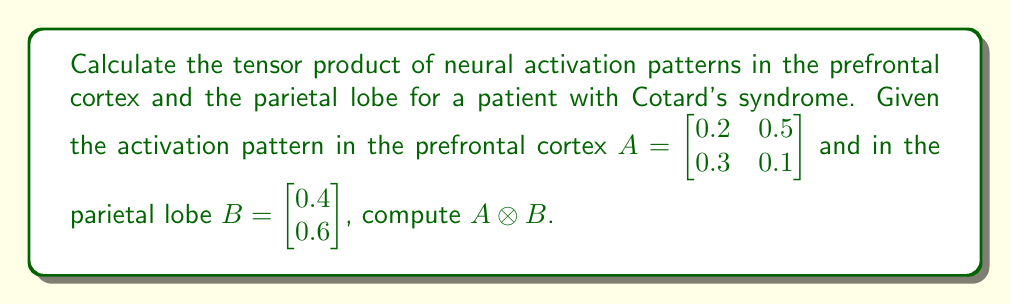Can you solve this math problem? To calculate the tensor product $A \otimes B$, we follow these steps:

1) The tensor product of a 2x2 matrix and a 2x1 vector results in a 4x2 matrix.

2) Each element of the resulting matrix is the product of an element from A and an element from B.

3) We can compute this systematically:

   $$(A \otimes B)_{ij,k} = A_{ij} \cdot B_k$$

   where $i,j \in \{1,2\}$ and $k \in \{1,2\}$

4) Let's compute each element:

   $$(A \otimes B)_{11,1} = A_{11} \cdot B_1 = 0.2 \cdot 0.4 = 0.08$$
   $$(A \otimes B)_{11,2} = A_{11} \cdot B_2 = 0.2 \cdot 0.6 = 0.12$$
   $$(A \otimes B)_{12,1} = A_{12} \cdot B_1 = 0.5 \cdot 0.4 = 0.20$$
   $$(A \otimes B)_{12,2} = A_{12} \cdot B_2 = 0.5 \cdot 0.6 = 0.30$$
   $$(A \otimes B)_{21,1} = A_{21} \cdot B_1 = 0.3 \cdot 0.4 = 0.12$$
   $$(A \otimes B)_{21,2} = A_{21} \cdot B_2 = 0.3 \cdot 0.6 = 0.18$$
   $$(A \otimes B)_{22,1} = A_{22} \cdot B_1 = 0.1 \cdot 0.4 = 0.04$$
   $$(A \otimes B)_{22,2} = A_{22} \cdot B_2 = 0.1 \cdot 0.6 = 0.06$$

5) Arranging these results in a 4x2 matrix gives us the final answer.
Answer: $$A \otimes B = \begin{bmatrix} 0.08 & 0.12 \\ 0.20 & 0.30 \\ 0.12 & 0.18 \\ 0.04 & 0.06 \end{bmatrix}$$ 